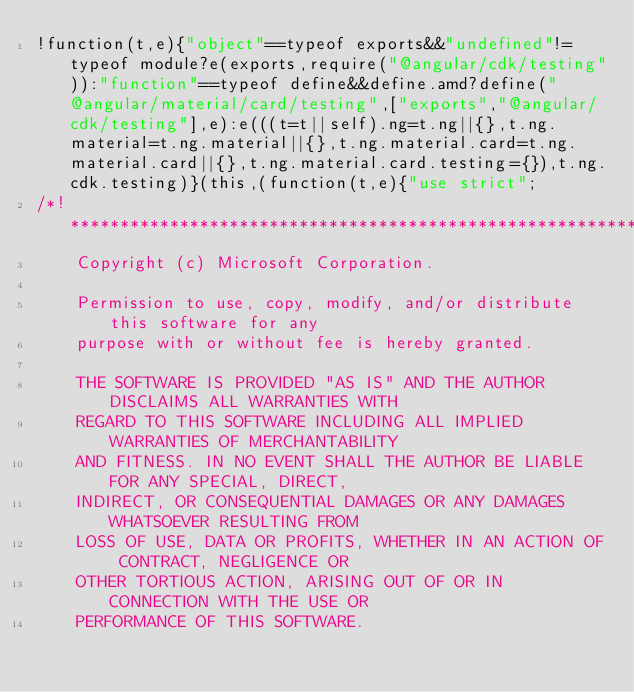Convert code to text. <code><loc_0><loc_0><loc_500><loc_500><_JavaScript_>!function(t,e){"object"==typeof exports&&"undefined"!=typeof module?e(exports,require("@angular/cdk/testing")):"function"==typeof define&&define.amd?define("@angular/material/card/testing",["exports","@angular/cdk/testing"],e):e(((t=t||self).ng=t.ng||{},t.ng.material=t.ng.material||{},t.ng.material.card=t.ng.material.card||{},t.ng.material.card.testing={}),t.ng.cdk.testing)}(this,(function(t,e){"use strict";
/*! *****************************************************************************
    Copyright (c) Microsoft Corporation.

    Permission to use, copy, modify, and/or distribute this software for any
    purpose with or without fee is hereby granted.

    THE SOFTWARE IS PROVIDED "AS IS" AND THE AUTHOR DISCLAIMS ALL WARRANTIES WITH
    REGARD TO THIS SOFTWARE INCLUDING ALL IMPLIED WARRANTIES OF MERCHANTABILITY
    AND FITNESS. IN NO EVENT SHALL THE AUTHOR BE LIABLE FOR ANY SPECIAL, DIRECT,
    INDIRECT, OR CONSEQUENTIAL DAMAGES OR ANY DAMAGES WHATSOEVER RESULTING FROM
    LOSS OF USE, DATA OR PROFITS, WHETHER IN AN ACTION OF CONTRACT, NEGLIGENCE OR
    OTHER TORTIOUS ACTION, ARISING OUT OF OR IN CONNECTION WITH THE USE OR
    PERFORMANCE OF THIS SOFTWARE.</code> 